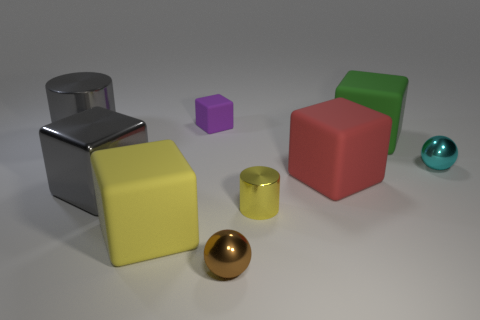There is a red object that is made of the same material as the big green thing; what shape is it? cube 